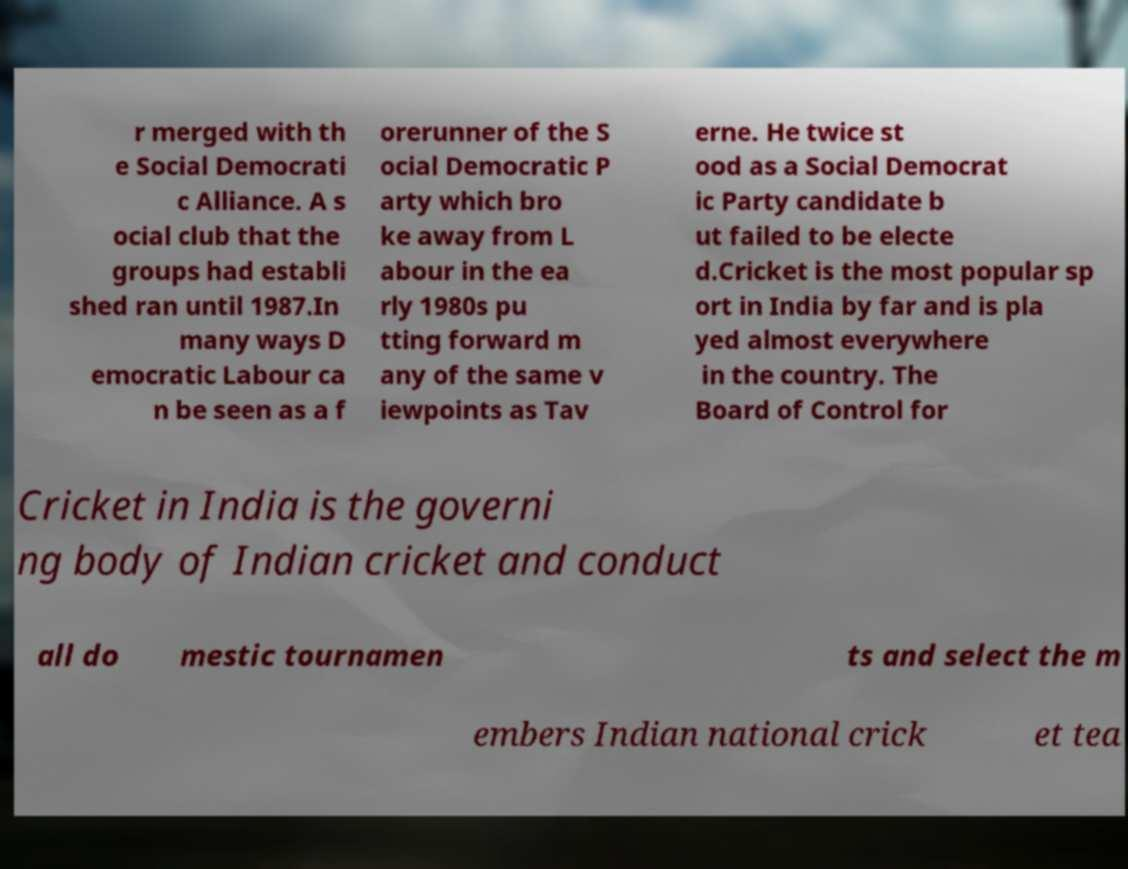Could you assist in decoding the text presented in this image and type it out clearly? r merged with th e Social Democrati c Alliance. A s ocial club that the groups had establi shed ran until 1987.In many ways D emocratic Labour ca n be seen as a f orerunner of the S ocial Democratic P arty which bro ke away from L abour in the ea rly 1980s pu tting forward m any of the same v iewpoints as Tav erne. He twice st ood as a Social Democrat ic Party candidate b ut failed to be electe d.Cricket is the most popular sp ort in India by far and is pla yed almost everywhere in the country. The Board of Control for Cricket in India is the governi ng body of Indian cricket and conduct all do mestic tournamen ts and select the m embers Indian national crick et tea 